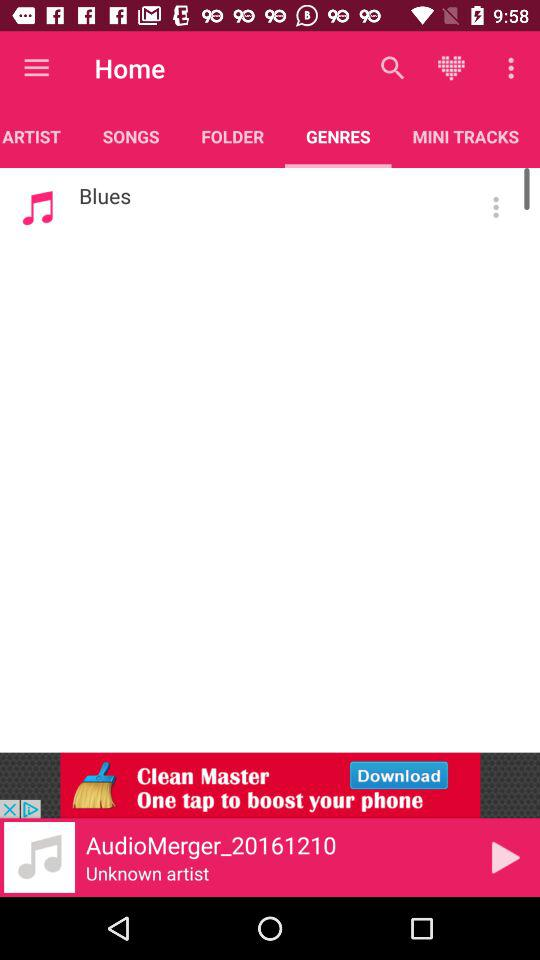Which tab is selected? The selected tab is "GENRES". 